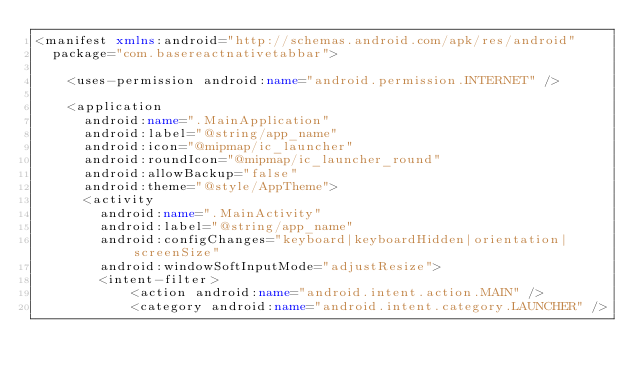Convert code to text. <code><loc_0><loc_0><loc_500><loc_500><_XML_><manifest xmlns:android="http://schemas.android.com/apk/res/android"
  package="com.basereactnativetabbar">

    <uses-permission android:name="android.permission.INTERNET" />

    <application
      android:name=".MainApplication"
      android:label="@string/app_name"
      android:icon="@mipmap/ic_launcher"
      android:roundIcon="@mipmap/ic_launcher_round"
      android:allowBackup="false"
      android:theme="@style/AppTheme">
      <activity
        android:name=".MainActivity"
        android:label="@string/app_name"
        android:configChanges="keyboard|keyboardHidden|orientation|screenSize"
        android:windowSoftInputMode="adjustResize">
        <intent-filter>
            <action android:name="android.intent.action.MAIN" />
            <category android:name="android.intent.category.LAUNCHER" /></code> 